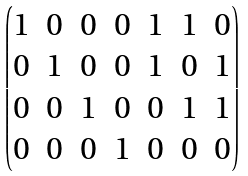Convert formula to latex. <formula><loc_0><loc_0><loc_500><loc_500>\begin{pmatrix} 1 & 0 & 0 & 0 & 1 & 1 & 0 \\ 0 & 1 & 0 & 0 & 1 & 0 & 1 \\ 0 & 0 & 1 & 0 & 0 & 1 & 1 \\ 0 & 0 & 0 & 1 & 0 & 0 & 0 \end{pmatrix}</formula> 